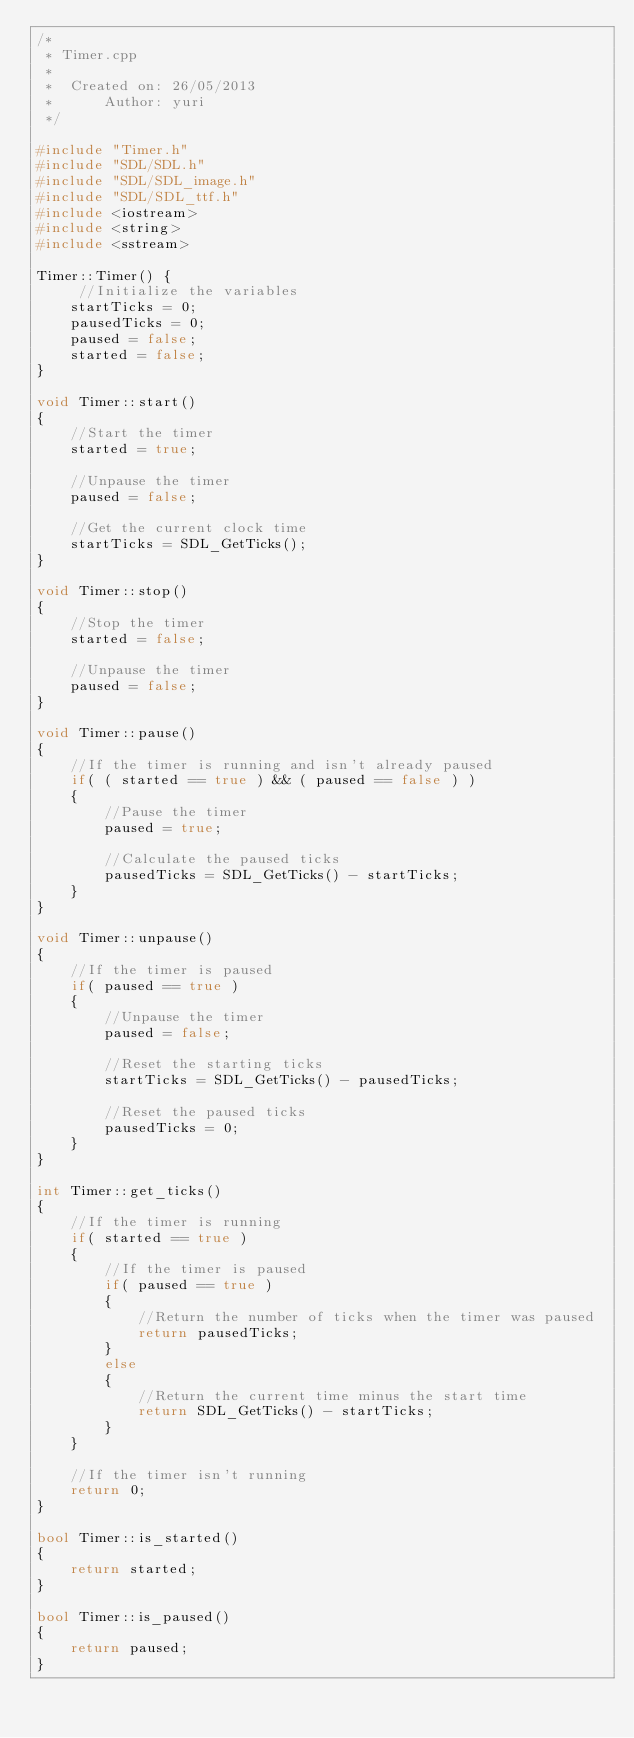Convert code to text. <code><loc_0><loc_0><loc_500><loc_500><_C++_>/*
 * Timer.cpp
 *
 *  Created on: 26/05/2013
 *      Author: yuri
 */

#include "Timer.h"
#include "SDL/SDL.h"
#include "SDL/SDL_image.h"
#include "SDL/SDL_ttf.h"
#include <iostream>
#include <string>
#include <sstream>

Timer::Timer() {
	 //Initialize the variables
	startTicks = 0;
	pausedTicks = 0;
	paused = false;
	started = false;
}

void Timer::start()
{
    //Start the timer
    started = true;

    //Unpause the timer
    paused = false;

    //Get the current clock time
    startTicks = SDL_GetTicks();
}

void Timer::stop()
{
    //Stop the timer
    started = false;

    //Unpause the timer
    paused = false;
}

void Timer::pause()
{
    //If the timer is running and isn't already paused
    if( ( started == true ) && ( paused == false ) )
    {
        //Pause the timer
        paused = true;

        //Calculate the paused ticks
        pausedTicks = SDL_GetTicks() - startTicks;
    }
}

void Timer::unpause()
{
    //If the timer is paused
    if( paused == true )
    {
        //Unpause the timer
        paused = false;

        //Reset the starting ticks
        startTicks = SDL_GetTicks() - pausedTicks;

        //Reset the paused ticks
        pausedTicks = 0;
    }
}

int Timer::get_ticks()
{
    //If the timer is running
    if( started == true )
    {
        //If the timer is paused
        if( paused == true )
        {
            //Return the number of ticks when the timer was paused
            return pausedTicks;
        }
        else
        {
            //Return the current time minus the start time
            return SDL_GetTicks() - startTicks;
        }
    }

    //If the timer isn't running
    return 0;
}

bool Timer::is_started()
{
    return started;
}

bool Timer::is_paused()
{
    return paused;
}
</code> 